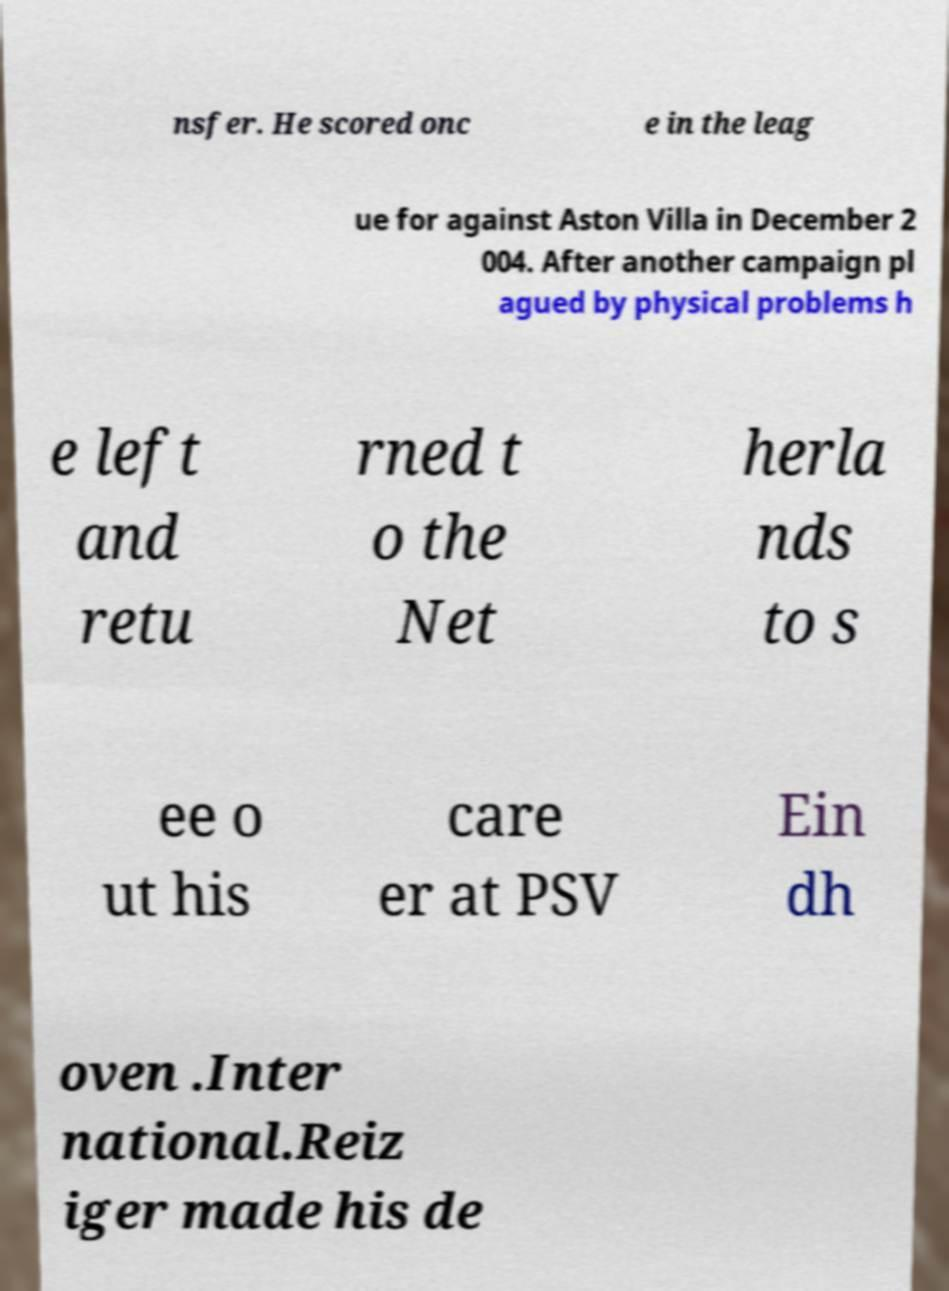I need the written content from this picture converted into text. Can you do that? nsfer. He scored onc e in the leag ue for against Aston Villa in December 2 004. After another campaign pl agued by physical problems h e left and retu rned t o the Net herla nds to s ee o ut his care er at PSV Ein dh oven .Inter national.Reiz iger made his de 